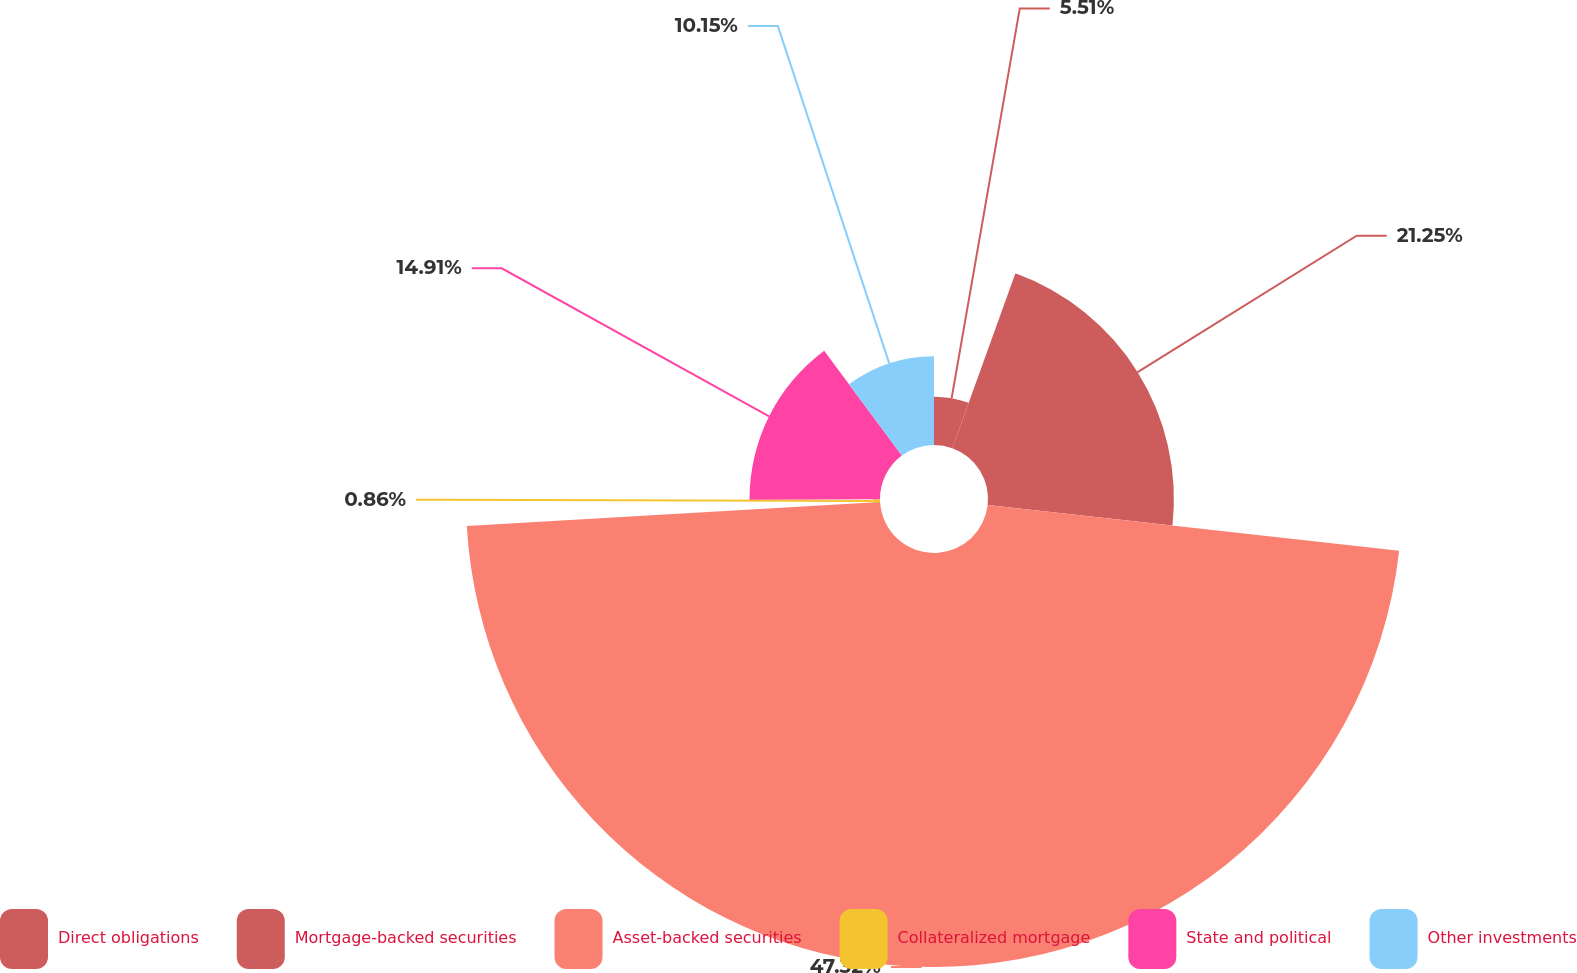Convert chart. <chart><loc_0><loc_0><loc_500><loc_500><pie_chart><fcel>Direct obligations<fcel>Mortgage-backed securities<fcel>Asset-backed securities<fcel>Collateralized mortgage<fcel>State and political<fcel>Other investments<nl><fcel>5.51%<fcel>21.25%<fcel>47.32%<fcel>0.86%<fcel>14.91%<fcel>10.15%<nl></chart> 